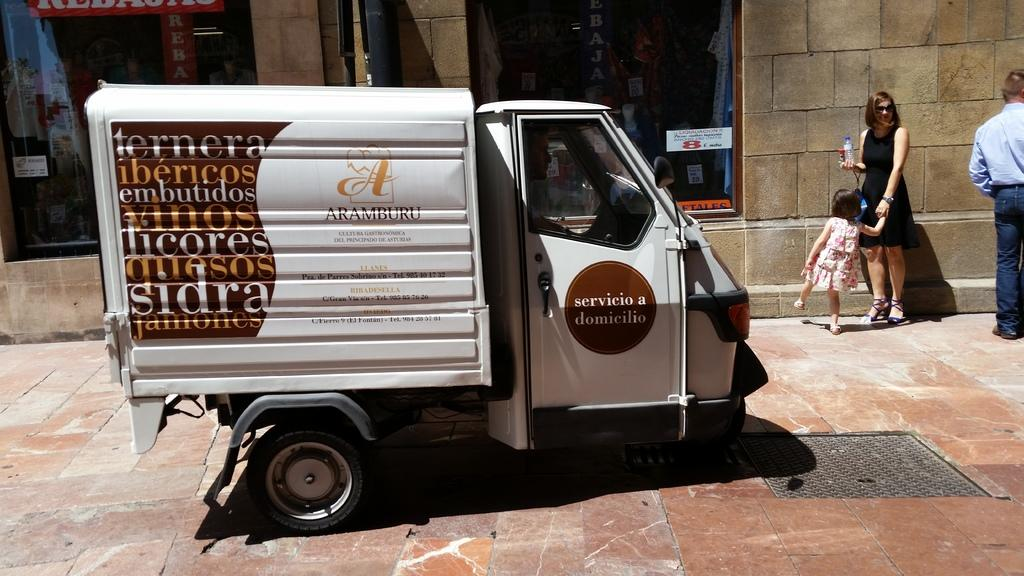What is the main subject of the image? There is a vehicle in the image. How many people are present in the image? There are three people standing on the right side of the image. What is behind the people in the image? The people are standing in front of a wall. How many windows are visible in the wall? There are two windows in the wall. What type of net is being used to catch the vehicle in the image? There is no net present in the image, and the vehicle is not being caught. 